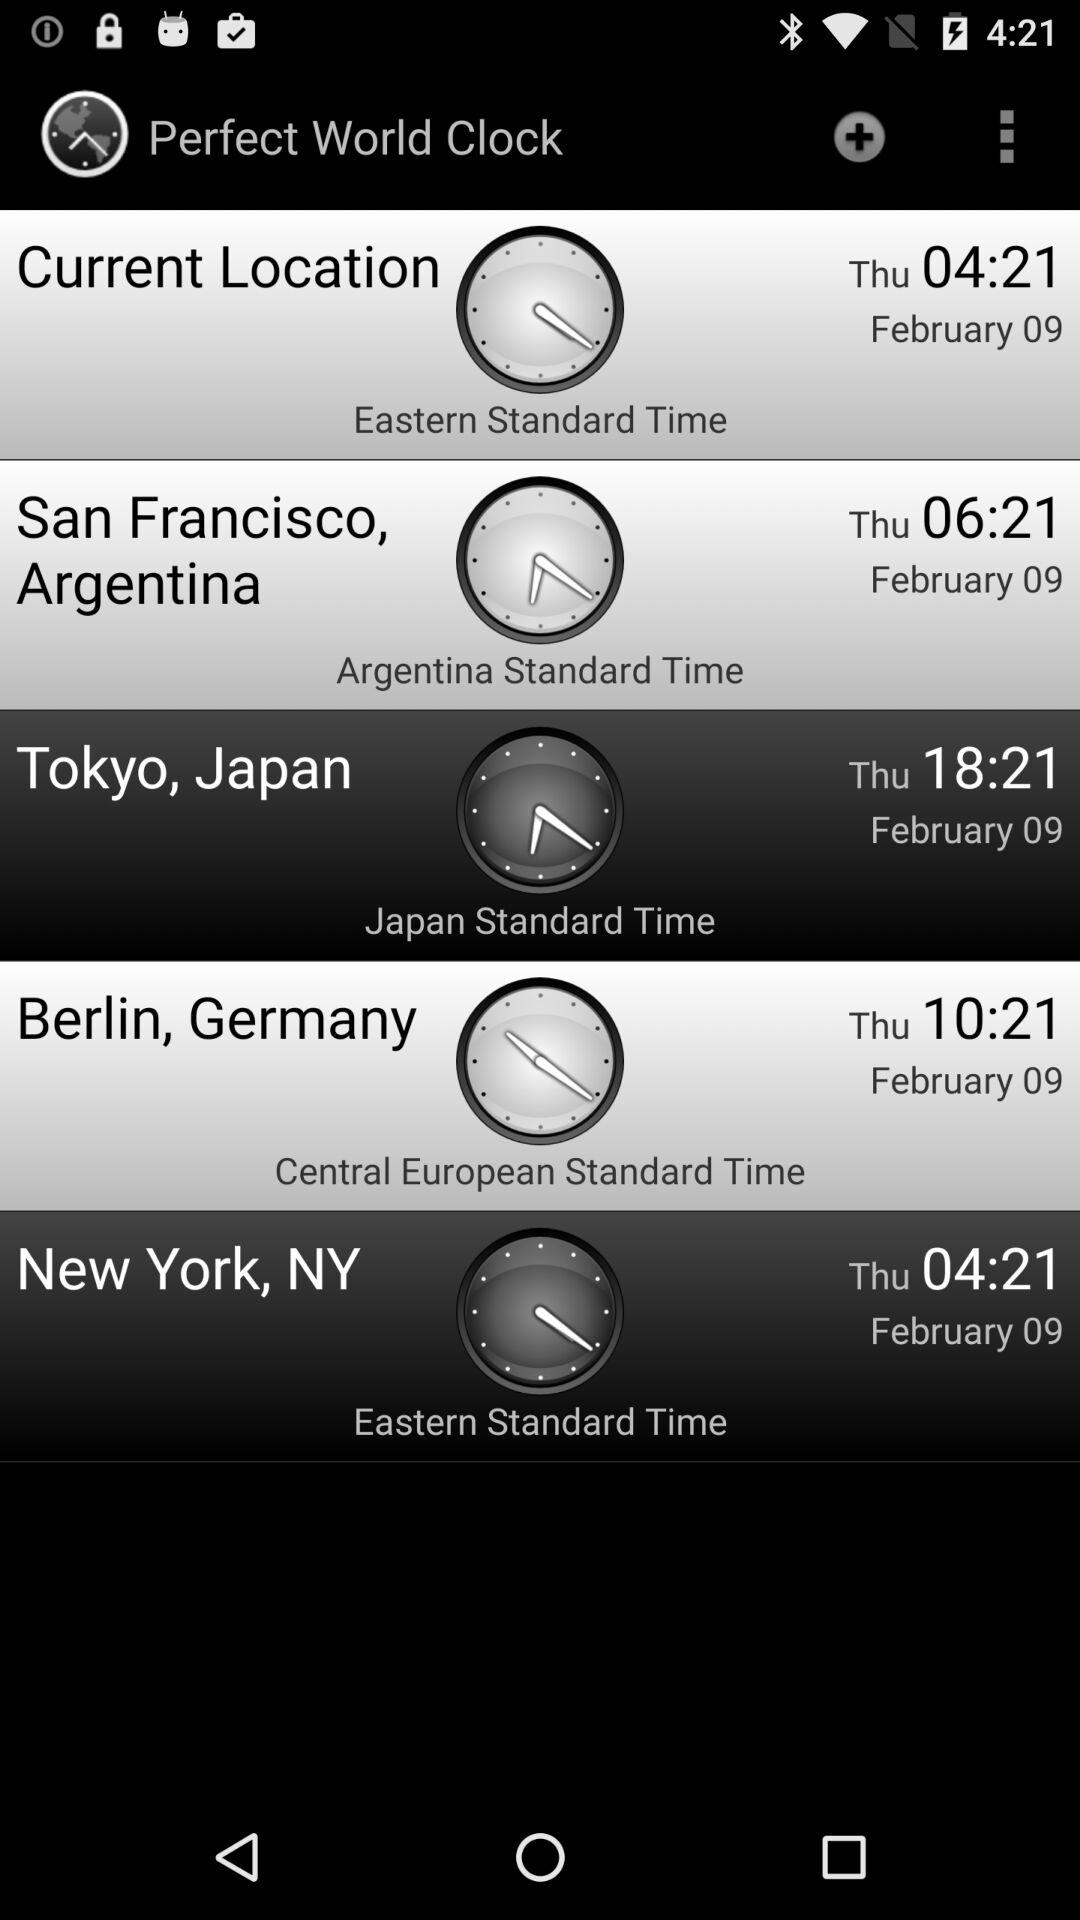Which day was February 9 in Argentina? The day was Thursday. 